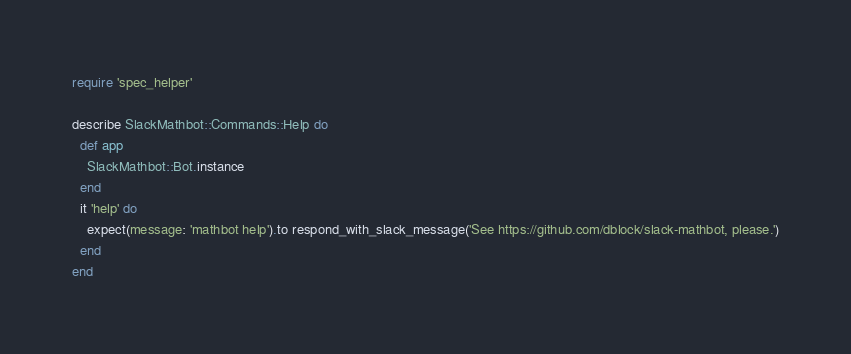<code> <loc_0><loc_0><loc_500><loc_500><_Ruby_>require 'spec_helper'

describe SlackMathbot::Commands::Help do
  def app
    SlackMathbot::Bot.instance
  end
  it 'help' do
    expect(message: 'mathbot help').to respond_with_slack_message('See https://github.com/dblock/slack-mathbot, please.')
  end
end
</code> 